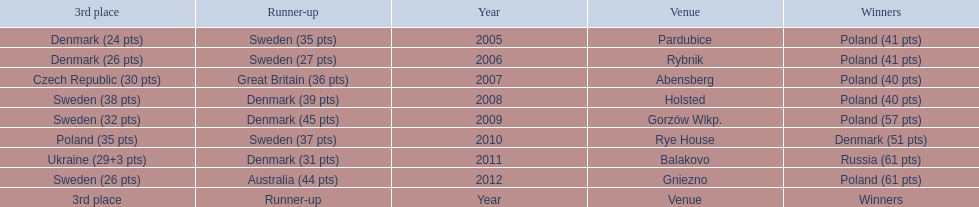After their first place win in 2009, how did poland place the next year at the speedway junior world championship? 3rd place. 